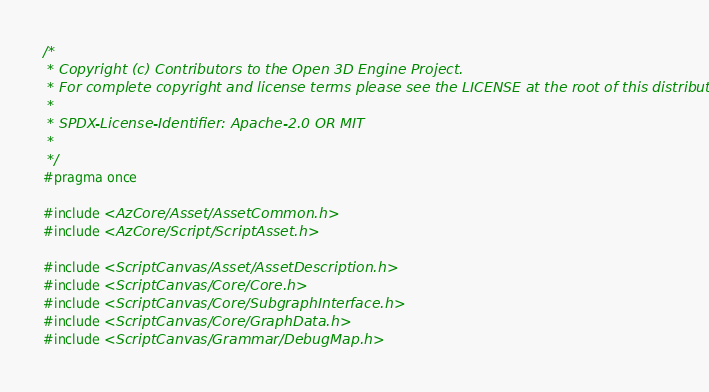<code> <loc_0><loc_0><loc_500><loc_500><_C_>/*
 * Copyright (c) Contributors to the Open 3D Engine Project.
 * For complete copyright and license terms please see the LICENSE at the root of this distribution.
 *
 * SPDX-License-Identifier: Apache-2.0 OR MIT
 *
 */
#pragma once

#include <AzCore/Asset/AssetCommon.h>
#include <AzCore/Script/ScriptAsset.h>

#include <ScriptCanvas/Asset/AssetDescription.h>
#include <ScriptCanvas/Core/Core.h>
#include <ScriptCanvas/Core/SubgraphInterface.h>
#include <ScriptCanvas/Core/GraphData.h>
#include <ScriptCanvas/Grammar/DebugMap.h></code> 